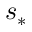<formula> <loc_0><loc_0><loc_500><loc_500>s _ { * }</formula> 